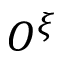<formula> <loc_0><loc_0><loc_500><loc_500>O ^ { \xi }</formula> 